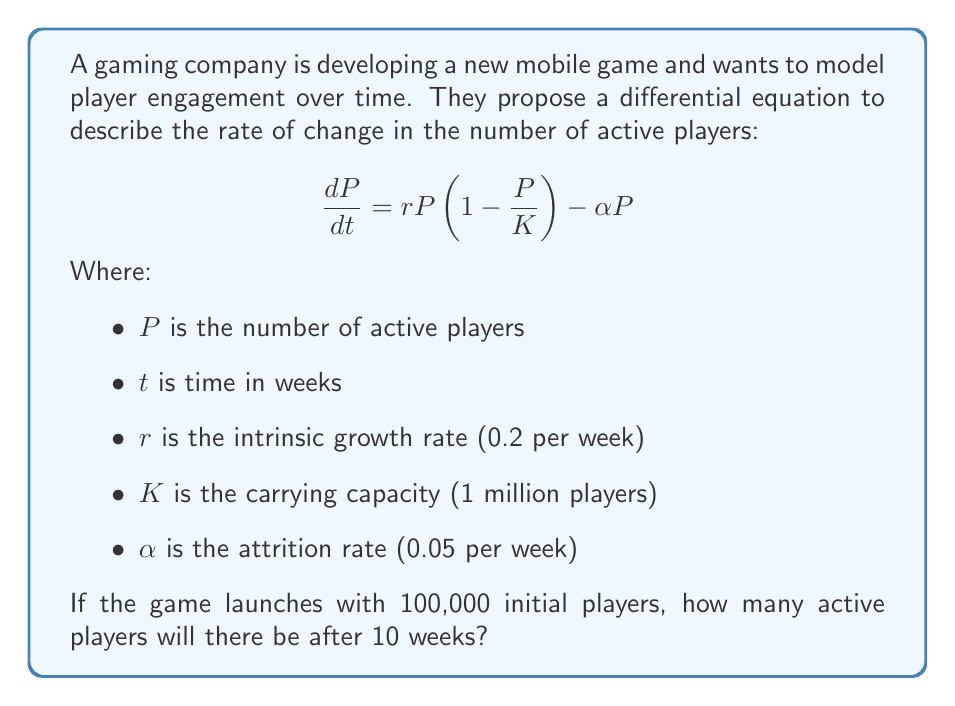Provide a solution to this math problem. To solve this problem, we need to use the given differential equation and initial condition to find the number of active players after 10 weeks. This is a logistic growth model with an additional term for player attrition.

1. First, we need to find the equilibrium points of the equation by setting $\frac{dP}{dt} = 0$:

   $$0 = rP(1 - \frac{P}{K}) - \alpha P$$
   $$0 = 0.2P(1 - \frac{P}{1,000,000}) - 0.05P$$

2. Solving this equation gives us two equilibrium points:
   $P = 0$ and $P = 750,000$

3. The non-zero equilibrium point (750,000) represents the long-term stable number of active players.

4. To find the number of players at a specific time, we need to solve the differential equation. However, this equation doesn't have a simple analytical solution. We can use numerical methods like Runge-Kutta to approximate the solution.

5. Using a fourth-order Runge-Kutta method with a small time step (e.g., 0.1 weeks), we can numerically integrate the differential equation from the initial condition ($P(0) = 100,000$) to $t = 10$ weeks.

6. Implementing this numerical method (which would typically be done using a computer program), we find that after 10 weeks, the number of active players is approximately 418,200.

This result shows significant growth from the initial 100,000 players, but it has not yet reached the long-term equilibrium of 750,000 players.
Answer: Approximately 418,200 active players after 10 weeks. 